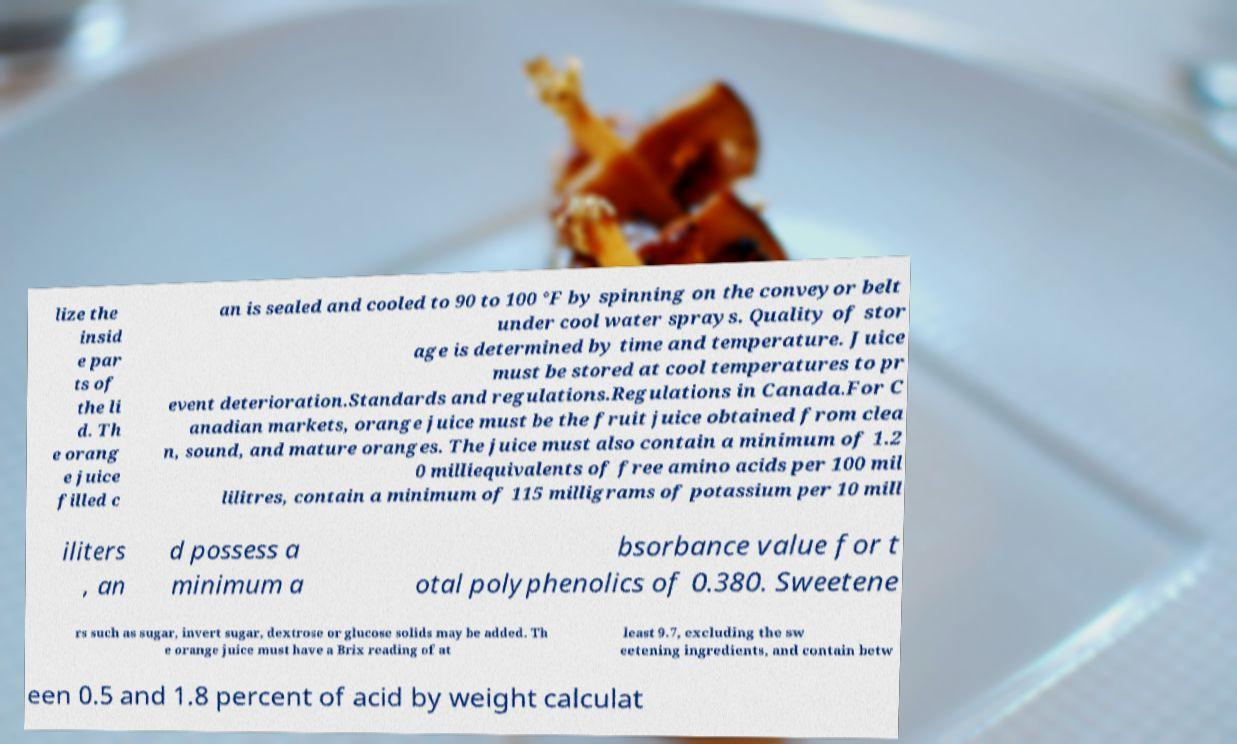What messages or text are displayed in this image? I need them in a readable, typed format. lize the insid e par ts of the li d. Th e orang e juice filled c an is sealed and cooled to 90 to 100 °F by spinning on the conveyor belt under cool water sprays. Quality of stor age is determined by time and temperature. Juice must be stored at cool temperatures to pr event deterioration.Standards and regulations.Regulations in Canada.For C anadian markets, orange juice must be the fruit juice obtained from clea n, sound, and mature oranges. The juice must also contain a minimum of 1.2 0 milliequivalents of free amino acids per 100 mil lilitres, contain a minimum of 115 milligrams of potassium per 10 mill iliters , an d possess a minimum a bsorbance value for t otal polyphenolics of 0.380. Sweetene rs such as sugar, invert sugar, dextrose or glucose solids may be added. Th e orange juice must have a Brix reading of at least 9.7, excluding the sw eetening ingredients, and contain betw een 0.5 and 1.8 percent of acid by weight calculat 